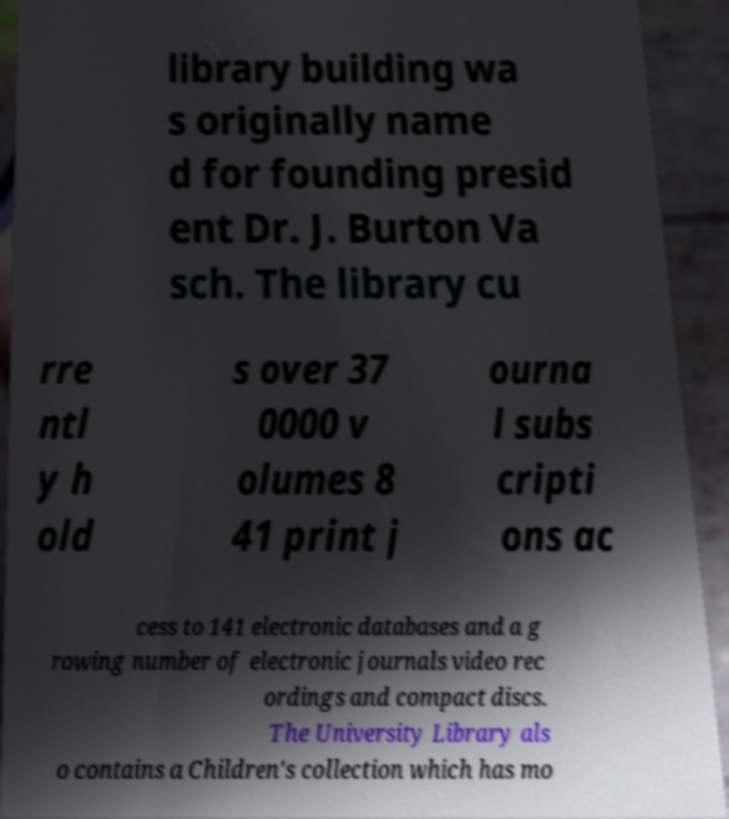Please identify and transcribe the text found in this image. library building wa s originally name d for founding presid ent Dr. J. Burton Va sch. The library cu rre ntl y h old s over 37 0000 v olumes 8 41 print j ourna l subs cripti ons ac cess to 141 electronic databases and a g rowing number of electronic journals video rec ordings and compact discs. The University Library als o contains a Children's collection which has mo 